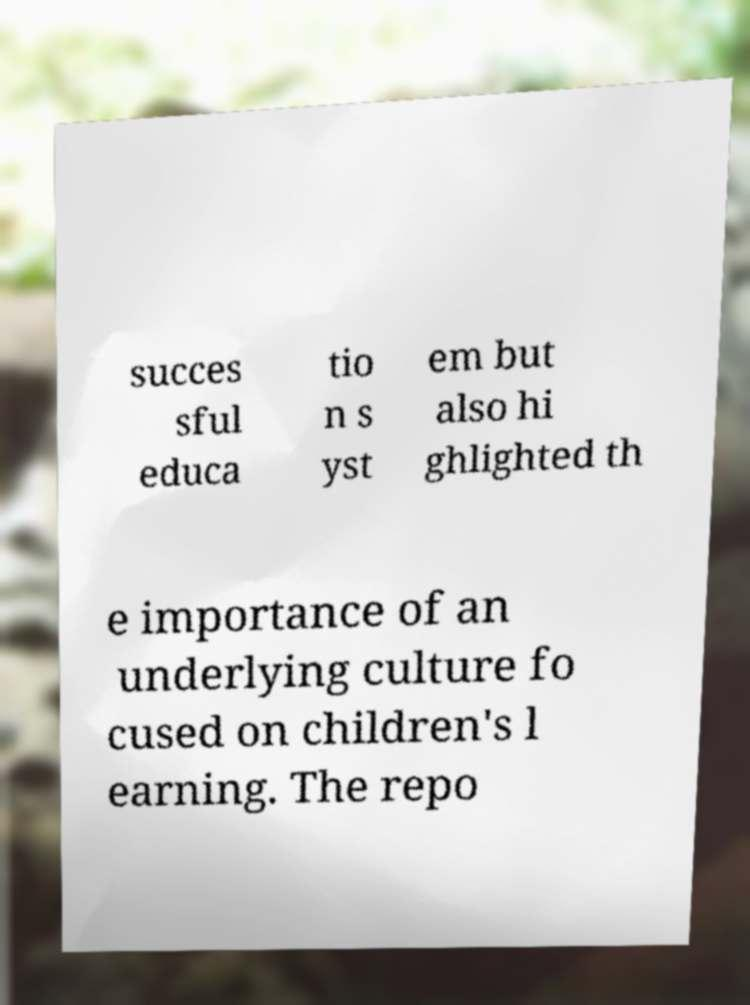For documentation purposes, I need the text within this image transcribed. Could you provide that? succes sful educa tio n s yst em but also hi ghlighted th e importance of an underlying culture fo cused on children's l earning. The repo 